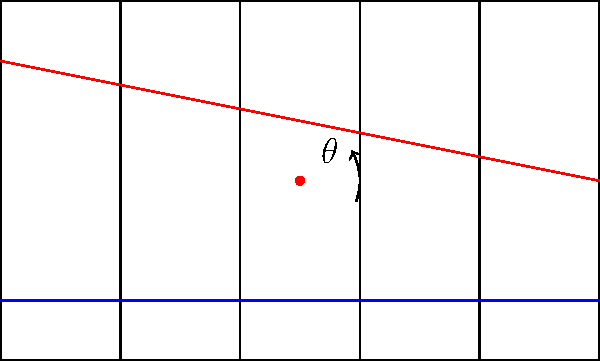In the fretboard diagram above, two guitar strings (represented by the blue and red lines) intersect. If the angle between these strings is $\theta$, calculate the value of $\theta$ given that the red string drops by 20 units over a length of 100 units on the fretboard. To solve this problem, let's follow these steps:

1) First, we need to understand that the angle $\theta$ is formed by the intersection of the blue (horizontal) string and the red (slanted) string.

2) The blue string is parallel to the fretboard, so it forms a horizontal line.

3) The red string drops by 20 units over a length of 100 units. This forms a right-angled triangle.

4) In this right-angled triangle:
   - The opposite side is 20 units (the vertical drop)
   - The adjacent side is 100 units (the horizontal length of the fretboard)

5) We can find $\theta$ using the inverse tangent function:

   $\theta = \tan^{-1}(\frac{\text{opposite}}{\text{adjacent}})$

6) Substituting our values:

   $\theta = \tan^{-1}(\frac{20}{100}) = \tan^{-1}(0.2)$

7) Using a calculator or trigonometric tables:

   $\theta \approx 11.31°$

Therefore, the angle formed by the intersecting guitar strings is approximately 11.31°.
Answer: $11.31°$ 